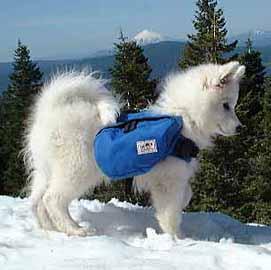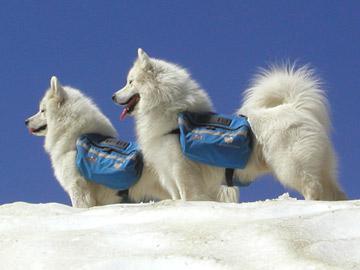The first image is the image on the left, the second image is the image on the right. Considering the images on both sides, is "There are two white dogs with blue packs in one image." valid? Answer yes or no. Yes. The first image is the image on the left, the second image is the image on the right. Considering the images on both sides, is "there are multiple dogs in blue backpacks" valid? Answer yes or no. Yes. 